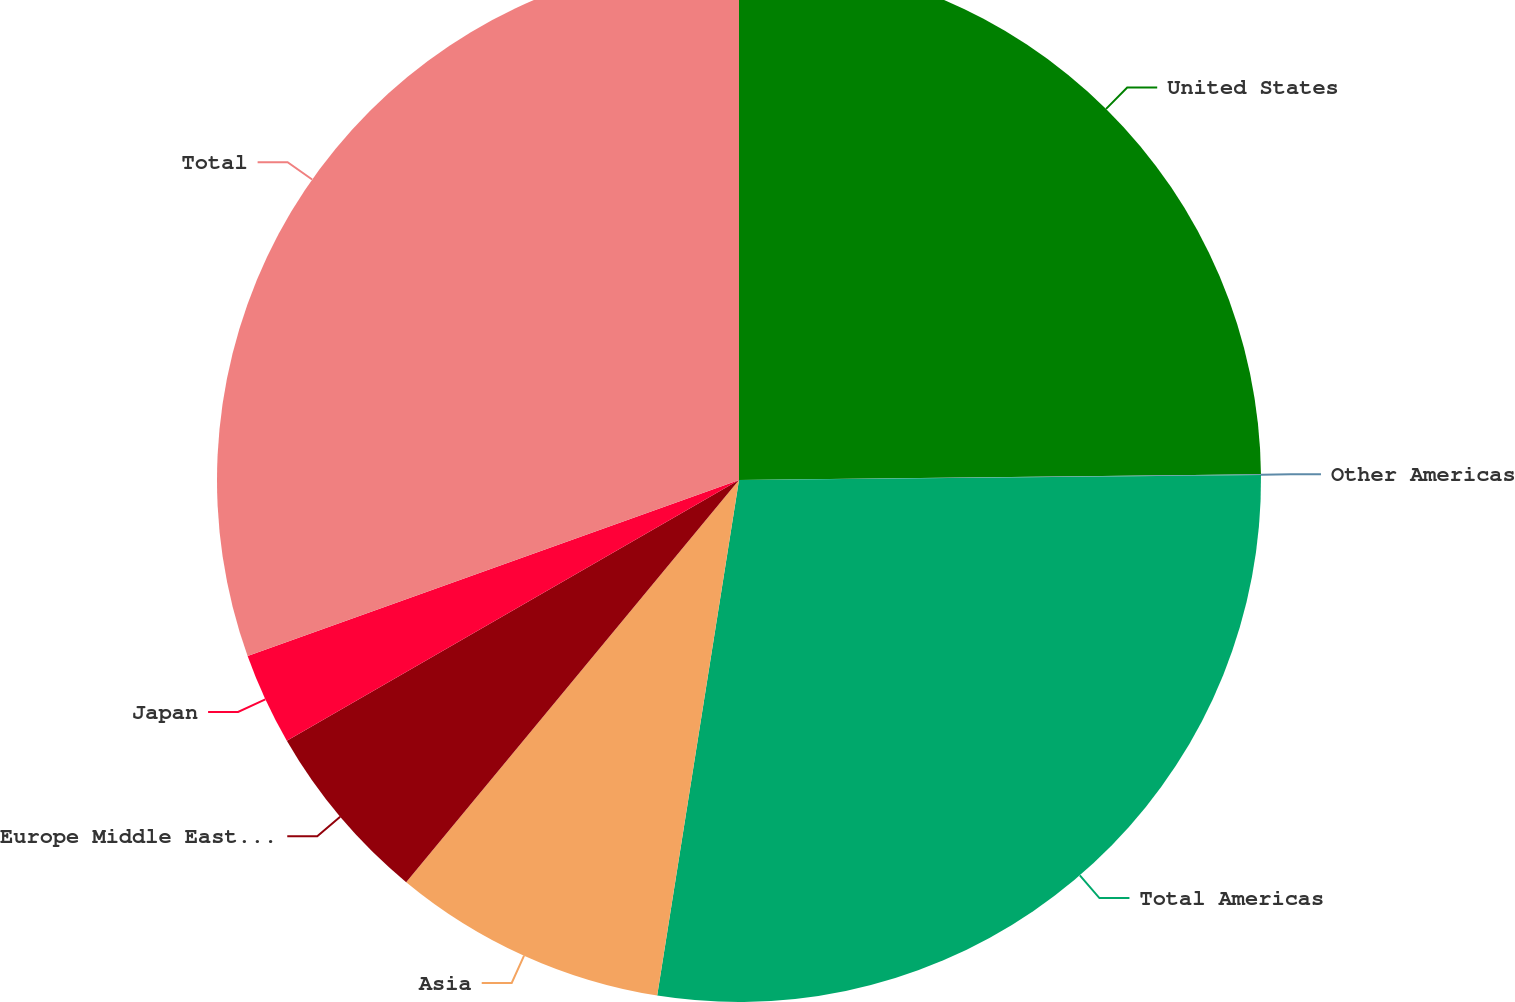<chart> <loc_0><loc_0><loc_500><loc_500><pie_chart><fcel>United States<fcel>Other Americas<fcel>Total Americas<fcel>Asia<fcel>Europe Middle East and Africa<fcel>Japan<fcel>Total<nl><fcel>24.83%<fcel>0.02%<fcel>27.66%<fcel>8.5%<fcel>5.67%<fcel>2.85%<fcel>30.48%<nl></chart> 